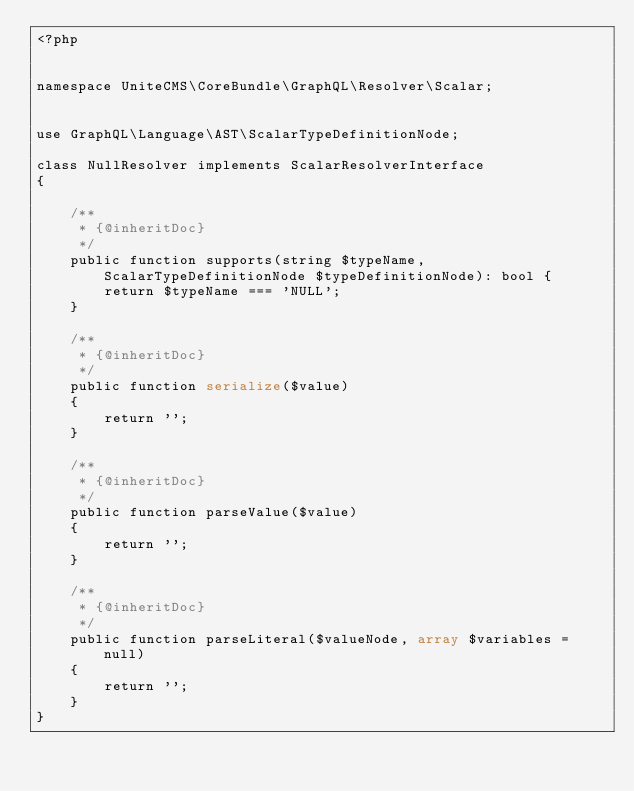Convert code to text. <code><loc_0><loc_0><loc_500><loc_500><_PHP_><?php


namespace UniteCMS\CoreBundle\GraphQL\Resolver\Scalar;


use GraphQL\Language\AST\ScalarTypeDefinitionNode;

class NullResolver implements ScalarResolverInterface
{

    /**
     * {@inheritDoc}
     */
    public function supports(string $typeName, ScalarTypeDefinitionNode $typeDefinitionNode): bool {
        return $typeName === 'NULL';
    }

    /**
     * {@inheritDoc}
     */
    public function serialize($value)
    {
        return '';
    }

    /**
     * {@inheritDoc}
     */
    public function parseValue($value)
    {
        return '';
    }

    /**
     * {@inheritDoc}
     */
    public function parseLiteral($valueNode, array $variables = null)
    {
        return '';
    }
}
</code> 